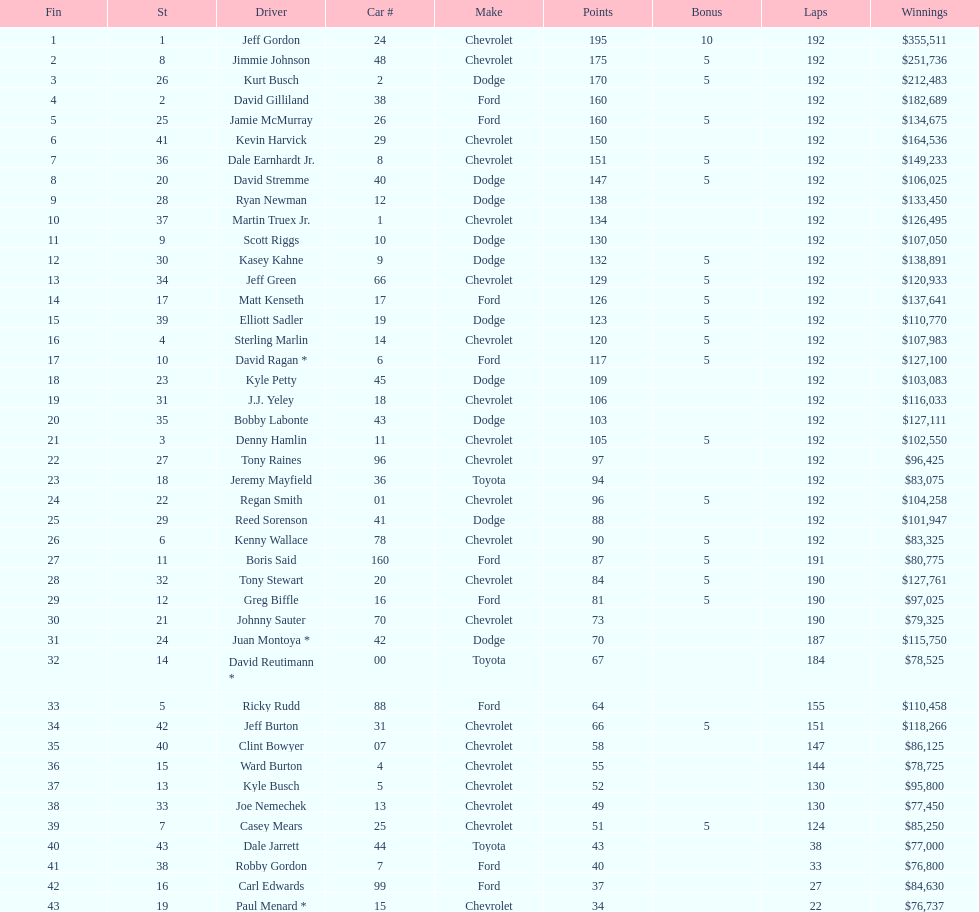Who received the highest number of bonus points? Jeff Gordon. 